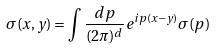Convert formula to latex. <formula><loc_0><loc_0><loc_500><loc_500>\sigma ( x , y ) = \int \frac { d p } { ( 2 \pi ) ^ { d } } e ^ { i p ( x - y ) } \sigma ( p )</formula> 